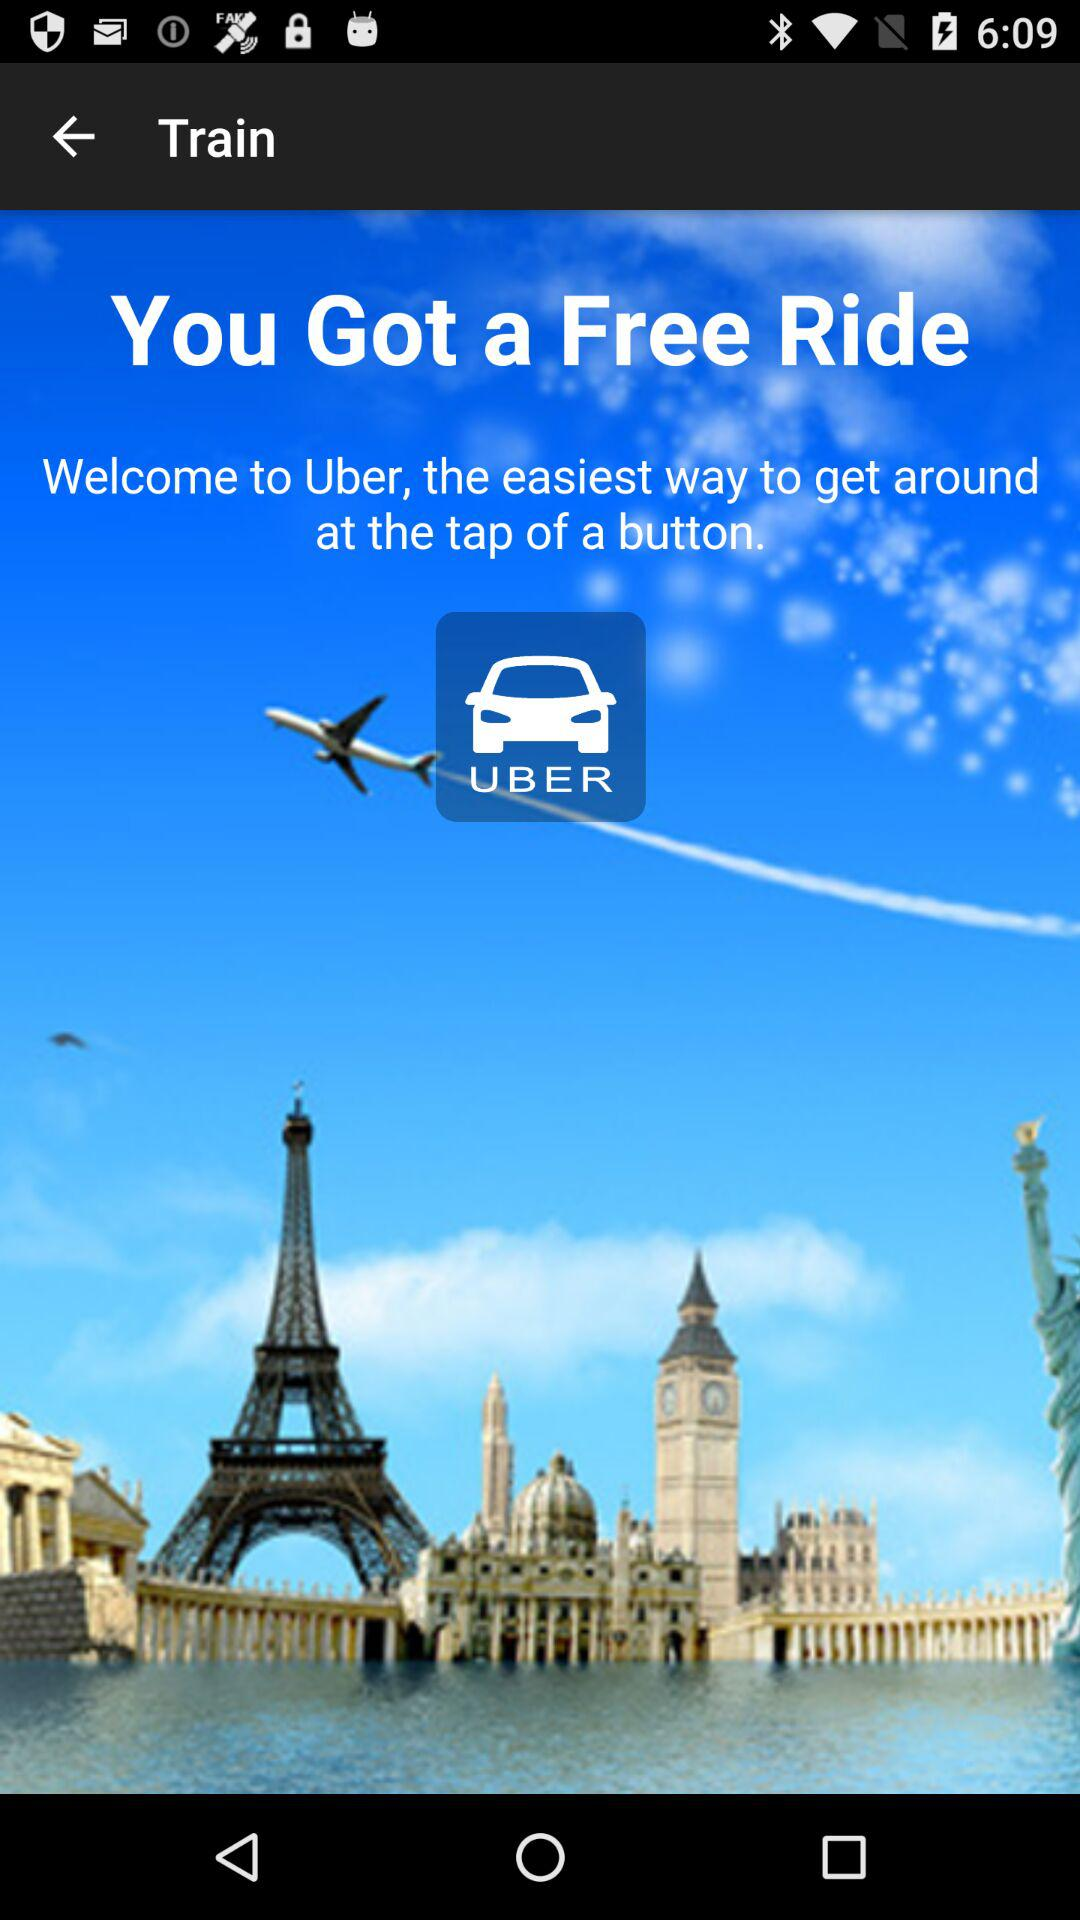What is the application name? The application name is "UBER". 